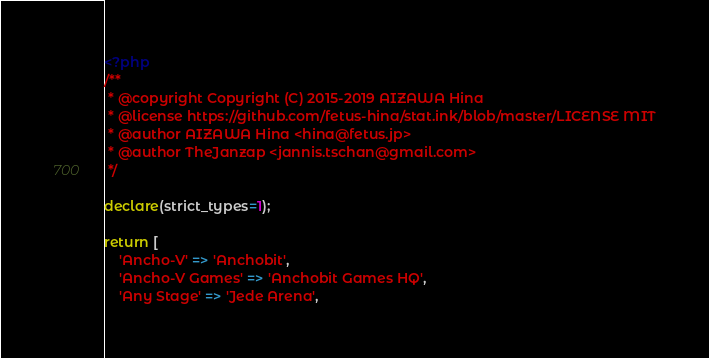Convert code to text. <code><loc_0><loc_0><loc_500><loc_500><_PHP_><?php
/**
 * @copyright Copyright (C) 2015-2019 AIZAWA Hina
 * @license https://github.com/fetus-hina/stat.ink/blob/master/LICENSE MIT
 * @author AIZAWA Hina <hina@fetus.jp>
 * @author TheJanzap <jannis.tschan@gmail.com>
 */

declare(strict_types=1);

return [
    'Ancho-V' => 'Anchobit',
    'Ancho-V Games' => 'Anchobit Games HQ',
    'Any Stage' => 'Jede Arena',</code> 